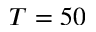Convert formula to latex. <formula><loc_0><loc_0><loc_500><loc_500>T = 5 0</formula> 